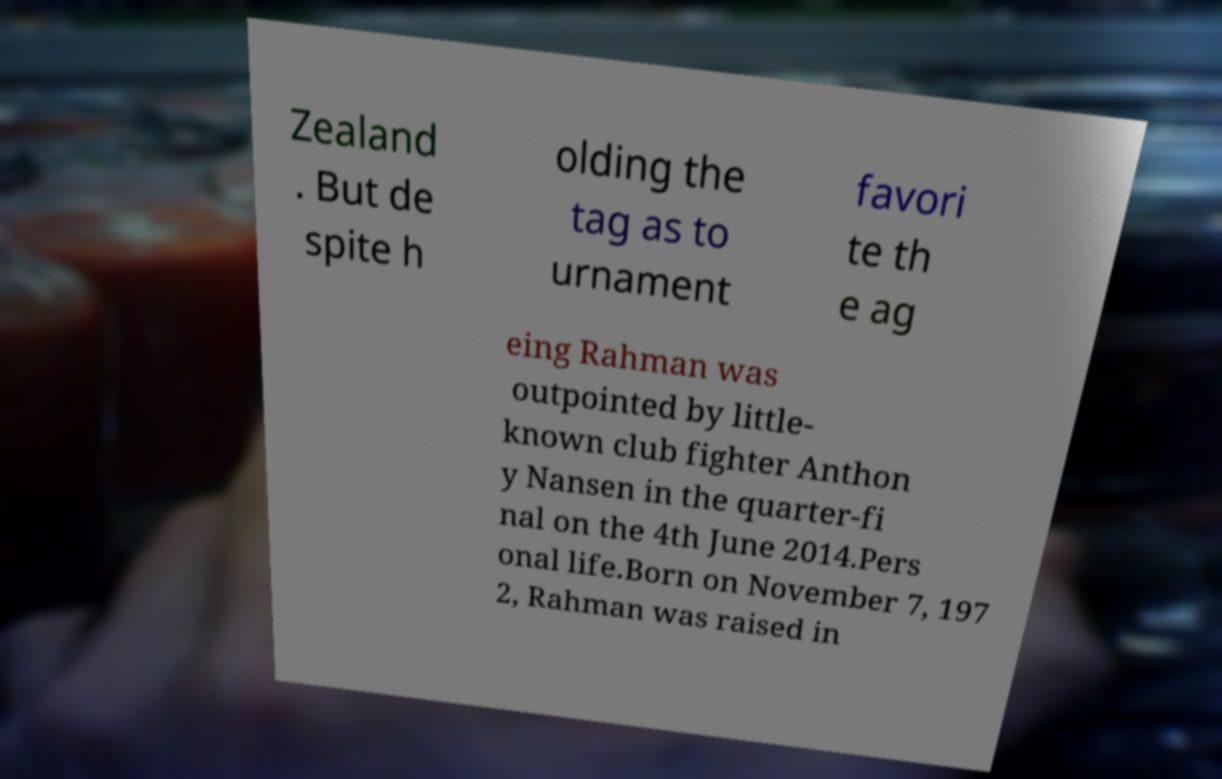Can you read and provide the text displayed in the image?This photo seems to have some interesting text. Can you extract and type it out for me? Zealand . But de spite h olding the tag as to urnament favori te th e ag eing Rahman was outpointed by little- known club fighter Anthon y Nansen in the quarter-fi nal on the 4th June 2014.Pers onal life.Born on November 7, 197 2, Rahman was raised in 